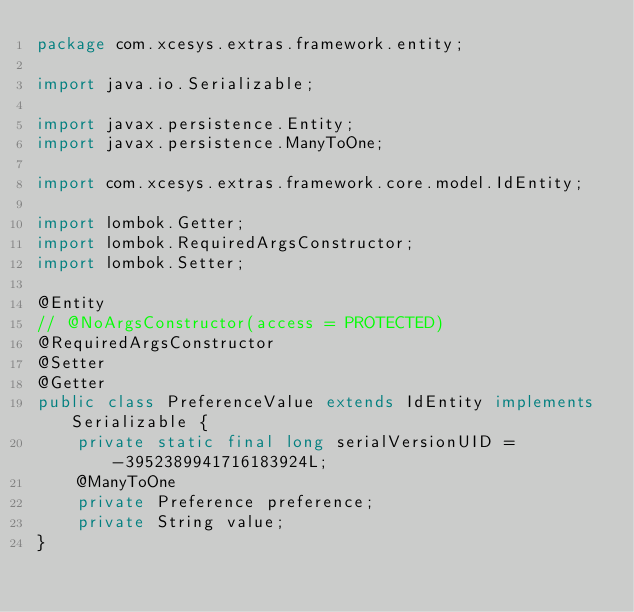Convert code to text. <code><loc_0><loc_0><loc_500><loc_500><_Java_>package com.xcesys.extras.framework.entity;

import java.io.Serializable;

import javax.persistence.Entity;
import javax.persistence.ManyToOne;

import com.xcesys.extras.framework.core.model.IdEntity;

import lombok.Getter;
import lombok.RequiredArgsConstructor;
import lombok.Setter;

@Entity
// @NoArgsConstructor(access = PROTECTED)
@RequiredArgsConstructor
@Setter
@Getter
public class PreferenceValue extends IdEntity implements Serializable {
	private static final long serialVersionUID = -3952389941716183924L;
	@ManyToOne
	private Preference preference;
	private String value;
}
</code> 